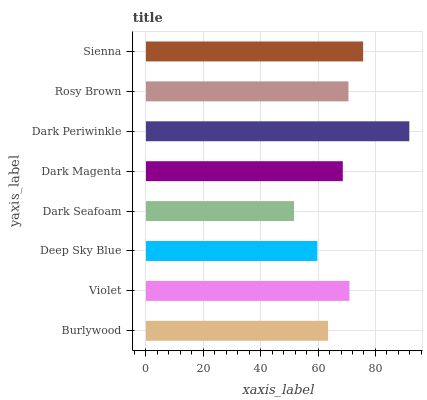Is Dark Seafoam the minimum?
Answer yes or no. Yes. Is Dark Periwinkle the maximum?
Answer yes or no. Yes. Is Violet the minimum?
Answer yes or no. No. Is Violet the maximum?
Answer yes or no. No. Is Violet greater than Burlywood?
Answer yes or no. Yes. Is Burlywood less than Violet?
Answer yes or no. Yes. Is Burlywood greater than Violet?
Answer yes or no. No. Is Violet less than Burlywood?
Answer yes or no. No. Is Rosy Brown the high median?
Answer yes or no. Yes. Is Dark Magenta the low median?
Answer yes or no. Yes. Is Deep Sky Blue the high median?
Answer yes or no. No. Is Burlywood the low median?
Answer yes or no. No. 